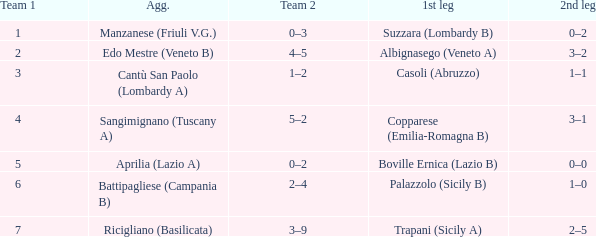When albignasego (veneto a) is the first leg, what is the mean value for team 1? 2.0. 